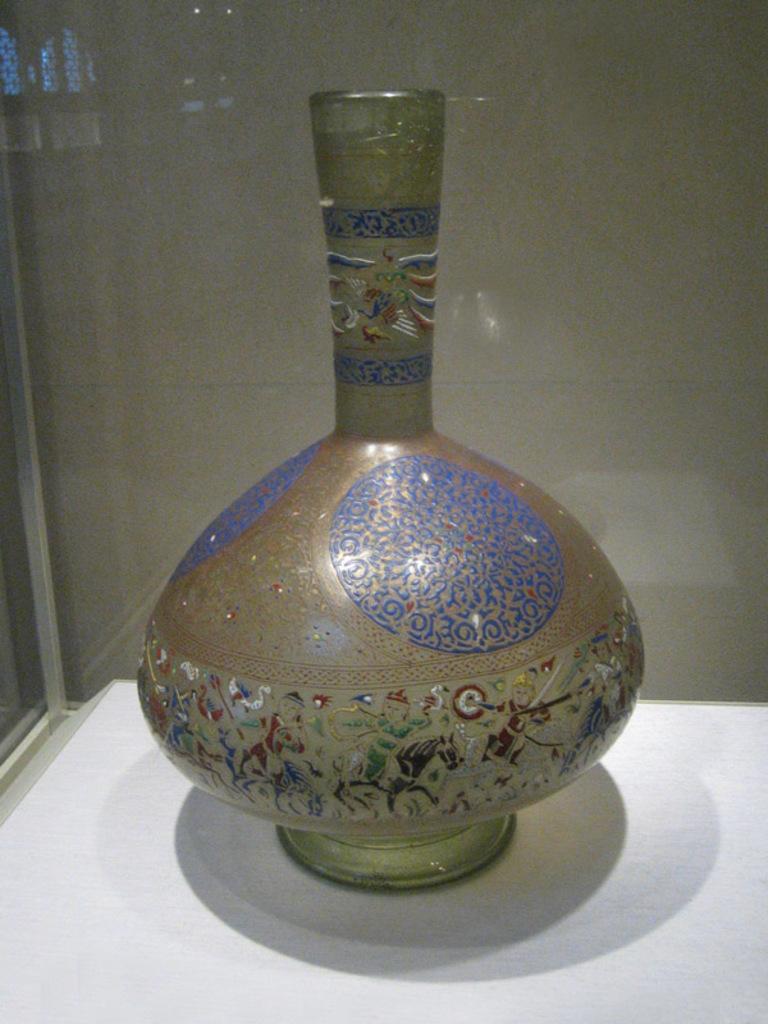In one or two sentences, can you explain what this image depicts? In the center of the image there is a port placed on the white surface. 